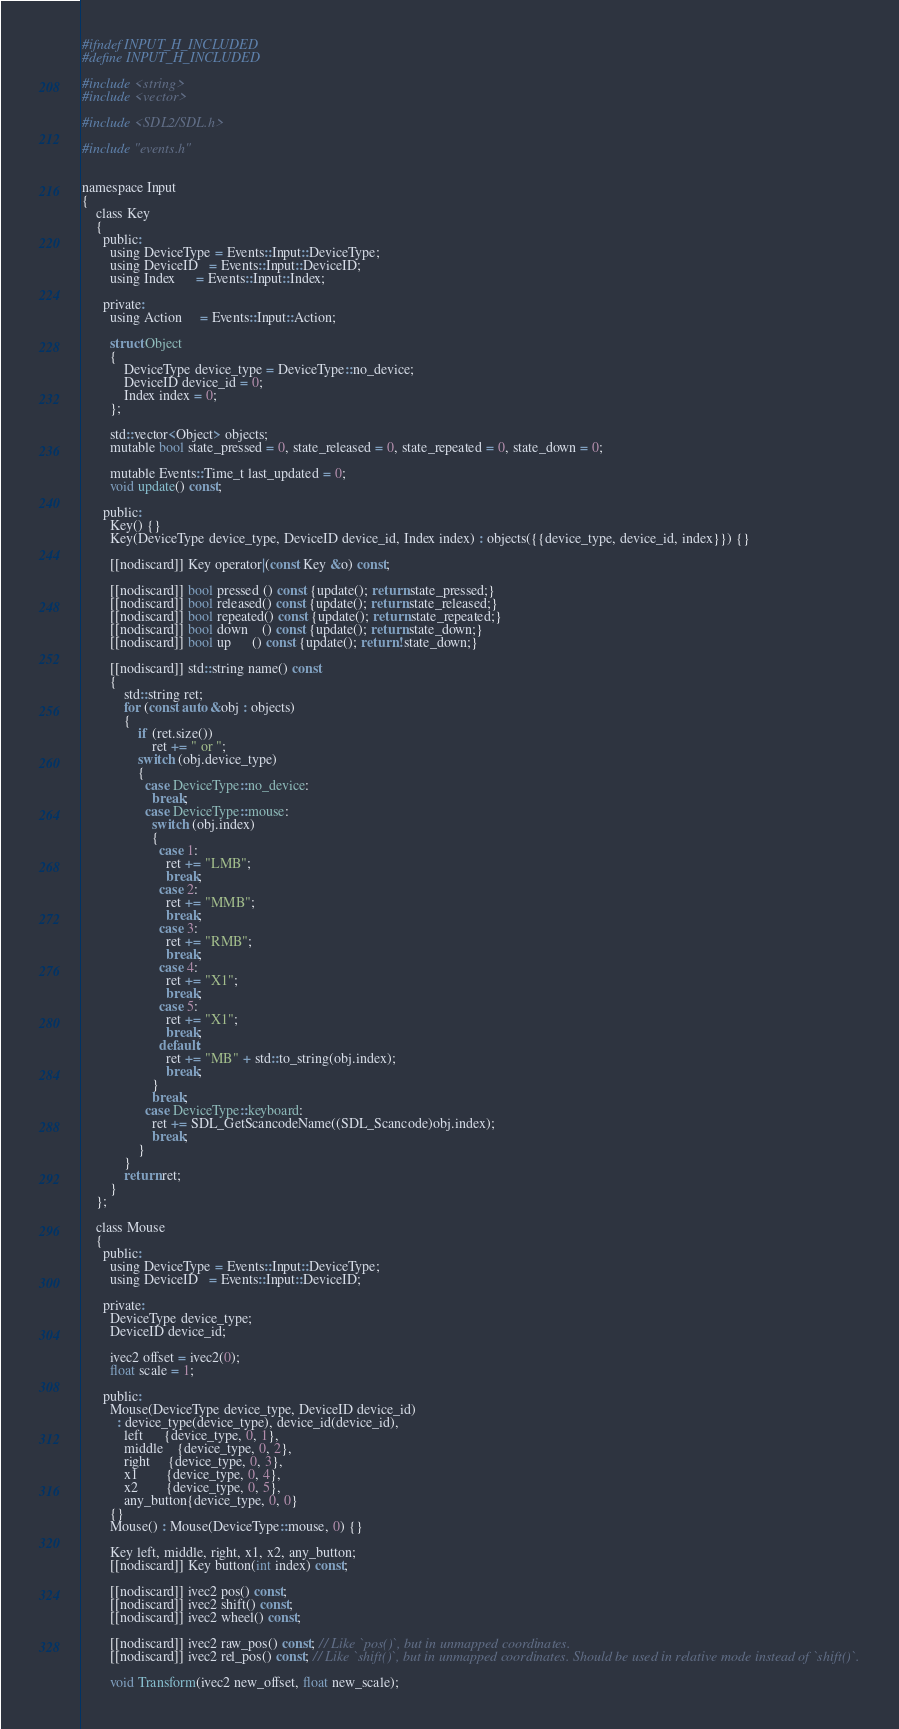Convert code to text. <code><loc_0><loc_0><loc_500><loc_500><_C_>#ifndef INPUT_H_INCLUDED
#define INPUT_H_INCLUDED

#include <string>
#include <vector>

#include <SDL2/SDL.h>

#include "events.h"


namespace Input
{
    class Key
    {
      public:
        using DeviceType = Events::Input::DeviceType;
        using DeviceID   = Events::Input::DeviceID;
        using Index      = Events::Input::Index;

      private:
        using Action     = Events::Input::Action;

        struct Object
        {
            DeviceType device_type = DeviceType::no_device;
            DeviceID device_id = 0;
            Index index = 0;
        };

        std::vector<Object> objects;
        mutable bool state_pressed = 0, state_released = 0, state_repeated = 0, state_down = 0;

        mutable Events::Time_t last_updated = 0;
        void update() const;

      public:
        Key() {}
        Key(DeviceType device_type, DeviceID device_id, Index index) : objects({{device_type, device_id, index}}) {}

        [[nodiscard]] Key operator|(const Key &o) const;

        [[nodiscard]] bool pressed () const {update(); return state_pressed;}
        [[nodiscard]] bool released() const {update(); return state_released;}
        [[nodiscard]] bool repeated() const {update(); return state_repeated;}
        [[nodiscard]] bool down    () const {update(); return state_down;}
        [[nodiscard]] bool up      () const {update(); return !state_down;}

        [[nodiscard]] std::string name() const
        {
            std::string ret;
            for (const auto &obj : objects)
            {
                if (ret.size())
                    ret += " or ";
                switch (obj.device_type)
                {
                  case DeviceType::no_device:
                    break;
                  case DeviceType::mouse:
                    switch (obj.index)
                    {
                      case 1:
                        ret += "LMB";
                        break;
                      case 2:
                        ret += "MMB";
                        break;
                      case 3:
                        ret += "RMB";
                        break;
                      case 4:
                        ret += "X1";
                        break;
                      case 5:
                        ret += "X1";
                        break;
                      default:
                        ret += "MB" + std::to_string(obj.index);
                        break;
                    }
                    break;
                  case DeviceType::keyboard:
                    ret += SDL_GetScancodeName((SDL_Scancode)obj.index);
                    break;
                }
            }
            return ret;
        }
    };

    class Mouse
    {
      public:
        using DeviceType = Events::Input::DeviceType;
        using DeviceID   = Events::Input::DeviceID;

      private:
        DeviceType device_type;
        DeviceID device_id;

        ivec2 offset = ivec2(0);
        float scale = 1;

      public:
        Mouse(DeviceType device_type, DeviceID device_id)
          : device_type(device_type), device_id(device_id),
            left      {device_type, 0, 1},
            middle    {device_type, 0, 2},
            right     {device_type, 0, 3},
            x1        {device_type, 0, 4},
            x2        {device_type, 0, 5},
            any_button{device_type, 0, 0}
        {}
        Mouse() : Mouse(DeviceType::mouse, 0) {}

        Key left, middle, right, x1, x2, any_button;
        [[nodiscard]] Key button(int index) const;

        [[nodiscard]] ivec2 pos() const;
        [[nodiscard]] ivec2 shift() const;
        [[nodiscard]] ivec2 wheel() const;

        [[nodiscard]] ivec2 raw_pos() const; // Like `pos()`, but in unmapped coordinates.
        [[nodiscard]] ivec2 rel_pos() const; // Like `shift()`, but in unmapped coordinates. Should be used in relative mode instead of `shift()`.

        void Transform(ivec2 new_offset, float new_scale);
</code> 